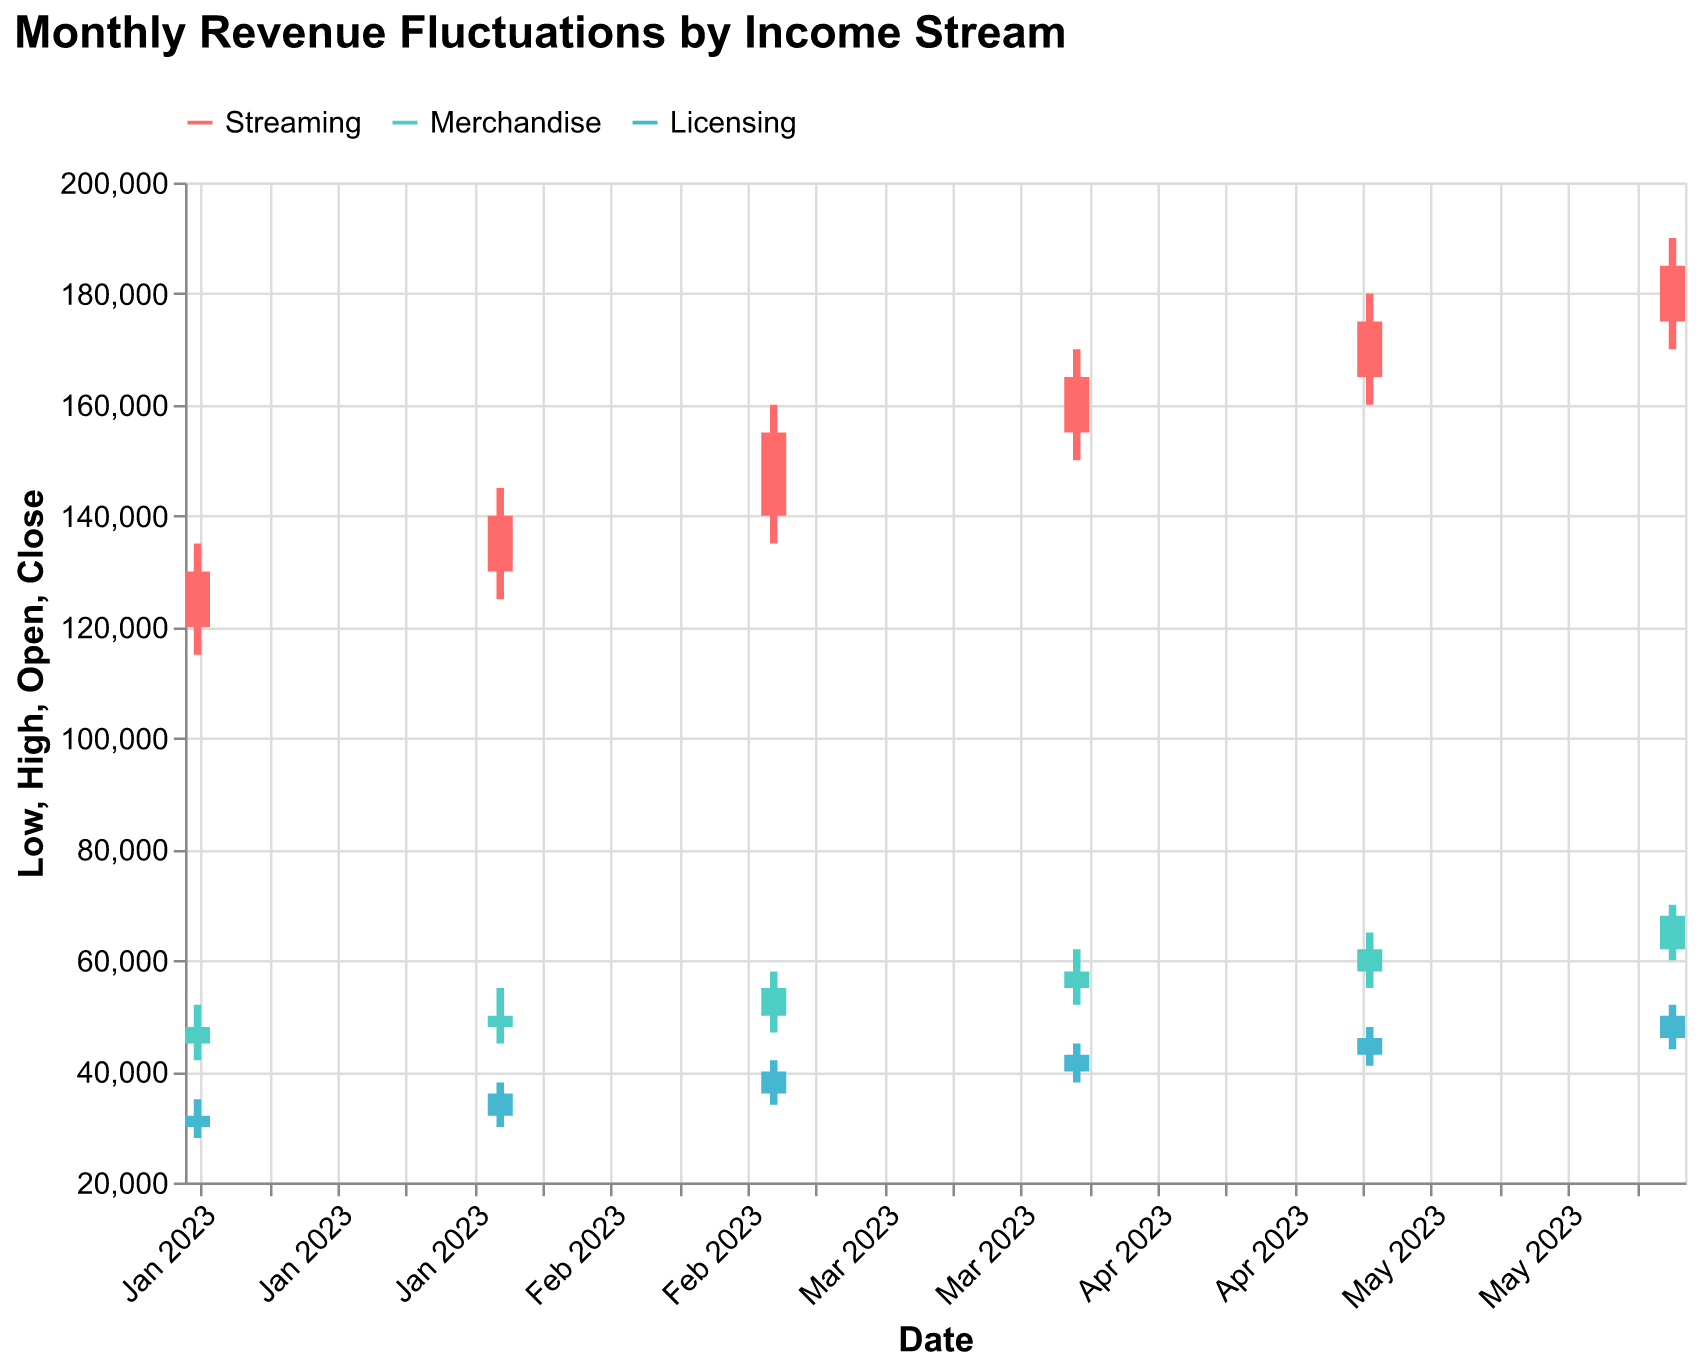What is the title of the figure? The title of the figure is prominently displayed at the top and reads, "Monthly Revenue Fluctuations by Income Stream".
Answer: Monthly Revenue Fluctuations by Income Stream Which month saw the highest closing value for streaming revenue? The highest closing value for streaming revenue can be observed at the highest point on the y-axis for the streaming income stream. The month with this highest point for the closing value is June 2023 with a close of 185000.
Answer: June 2023 What is the low value for merchandise revenue in April 2023? To find this, locate April 2023 on the x-axis and check the merchandise stream (indicated by its specific color). The low value for merchandise revenue is represented by the bottom of the vertical lines in the OHLC chart. For April 2023, it is 52,000.
Answer: 52,000 How did the closing value for licensing revenue change from May to June 2023? Compare the closing values for licensing revenue in May and June. May's value is 46,000, while June's is 50,000. The change is 50,000 - 46,000 = 4,000.
Answer: Increased by 4,000 What is the average closing value for streaming revenue over the six months? Sum the closing values for streaming revenue from January to June, which are: 130000, 140000, 155000, 165000, 175000, and 185000. The total sum is 950000. Then, divide this sum by 6 to get the average, 950000 / 6 = 158333.33.
Answer: 158333.33 Which income stream had the smallest range of high and low values in March 2023? To determine this, calculate the range for each income stream in March 2023. 
For Streaming: 160000 - 135000 = 25000
For Merchandise: 58000 - 47000 = 11000
For Licensing: 42000 - 34000 = 8000
The smallest range is for Licensing.
Answer: Licensing How much did the licensing revenue's high value increase from February 2023 to March 2023? Find the high values for February and March for licensing revenue. In February, it is 38,000 and in March, it is 42,000. The increase is 42,000 - 38,000 = 4,000.
Answer: 4,000 Which month experienced the largest increase in streaming revenue's closing value compared to the previous month? Calculate the difference in the closing value for streaming revenue for each month compared to the previous one.
From Jan to Feb: 140000 - 130000 = 10000
From Feb to Mar: 155000 - 140000 = 15000
From Mar to Apr: 165000 - 155000 = 10000
From Apr to May: 175000 - 165000 = 10000
From May to Jun: 185000 - 175000 = 10000
The largest increase is from February to March with a difference of 15,000.
Answer: February to March 